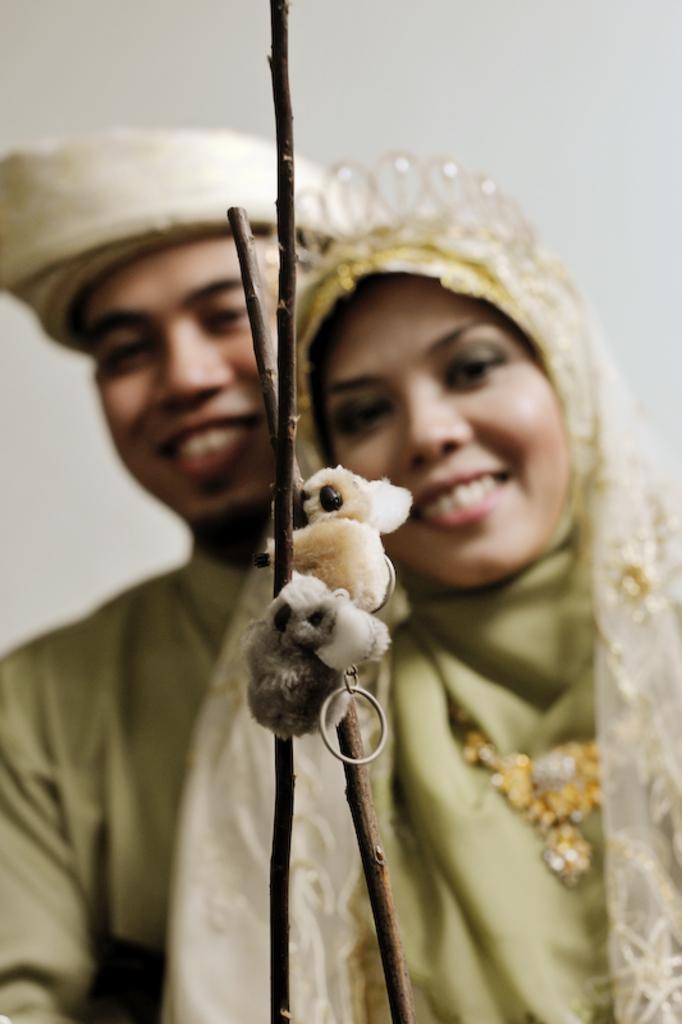Can you describe this image briefly? In this image we can see key chains to the wooden sticks. The background of the image is slightly blurred, where we can see a man and woman are standing and the white color wall. 